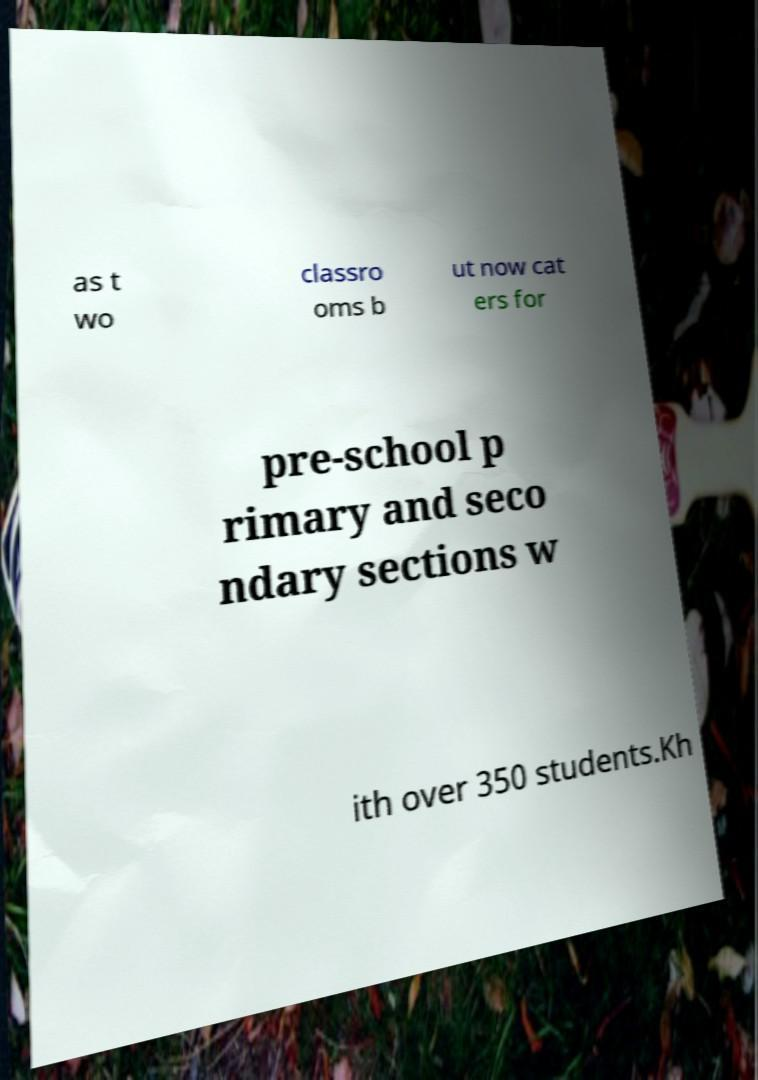There's text embedded in this image that I need extracted. Can you transcribe it verbatim? as t wo classro oms b ut now cat ers for pre-school p rimary and seco ndary sections w ith over 350 students.Kh 